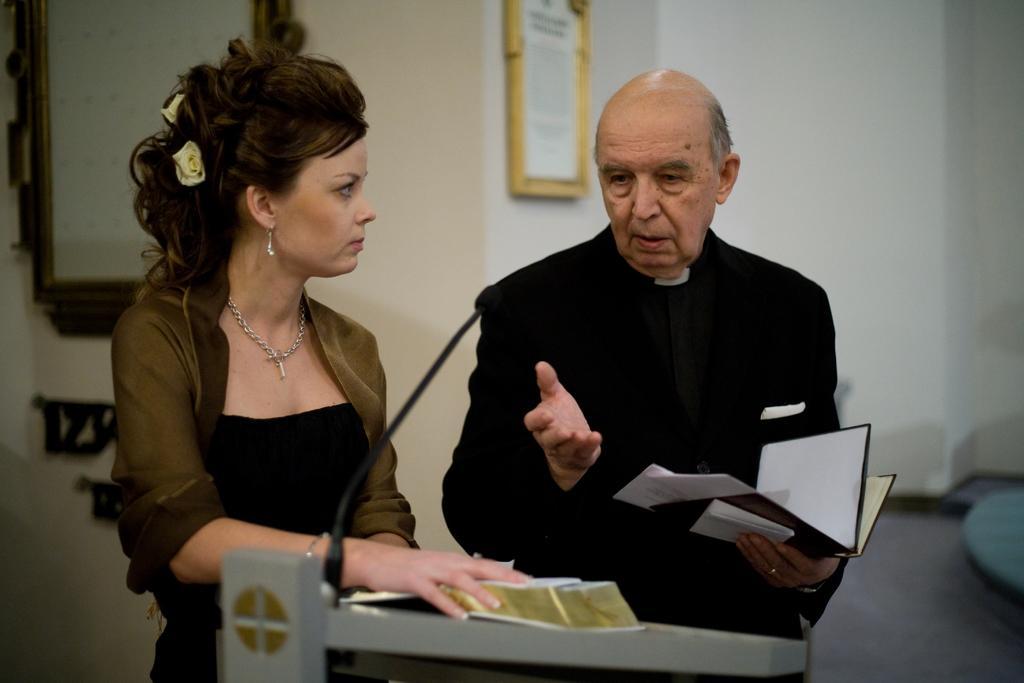Please provide a concise description of this image. In this image there is a man and a woman standing. The man is holding a book in his hand. In front of them there is a podium. There are books and a microphone on the podium. Behind them there is a wall. There are picture frames on the wall. 